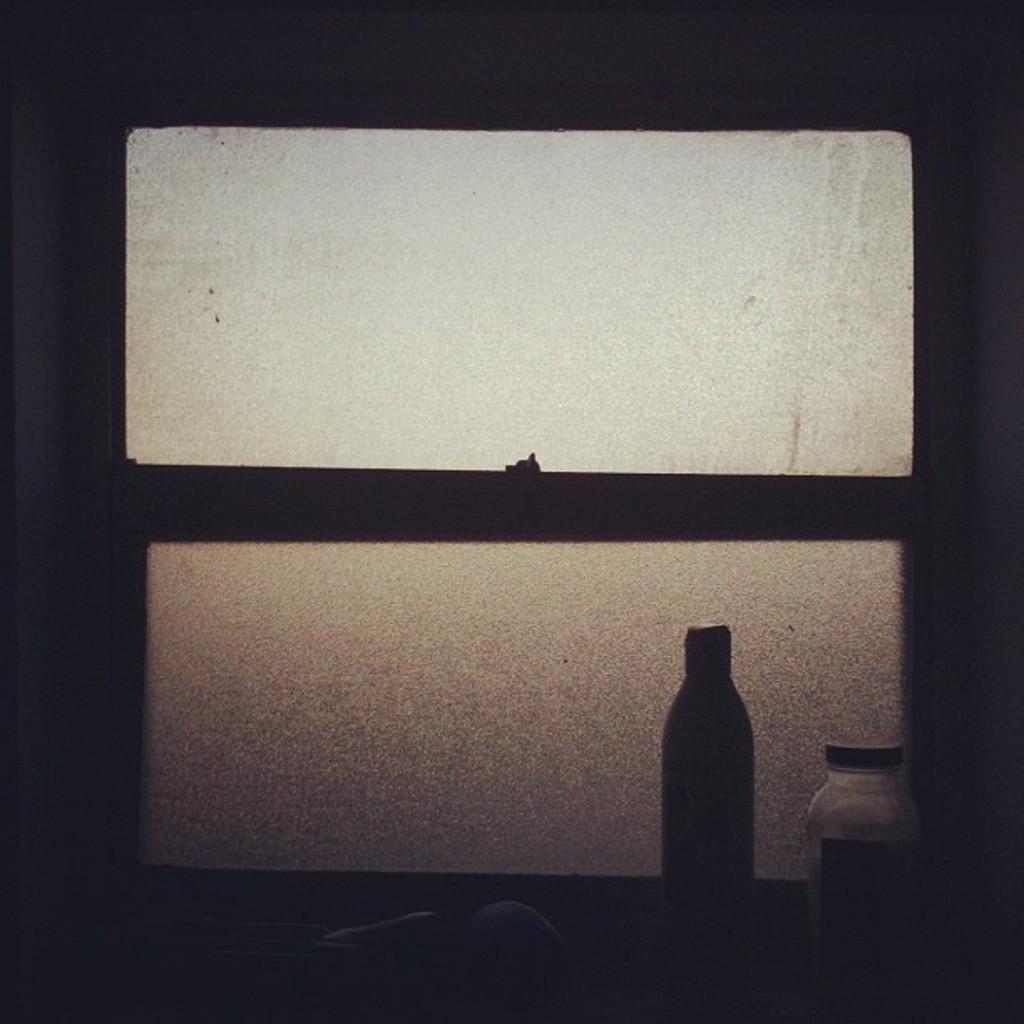Describe this image in one or two sentences. In this picture there is a window at the center of the image and there is a bottle at the right side of the image. 